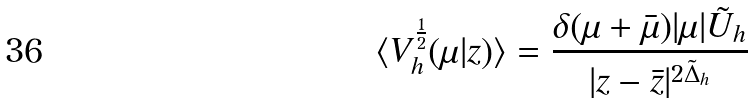Convert formula to latex. <formula><loc_0><loc_0><loc_500><loc_500>\langle V ^ { \frac { 1 } { 2 } } _ { h } ( \mu | z ) \rangle = \frac { \delta ( \mu + \bar { \mu } ) | \mu | \tilde { U } _ { h } } { | z - \bar { z } | ^ { 2 \tilde { \Delta } _ { h } } }</formula> 